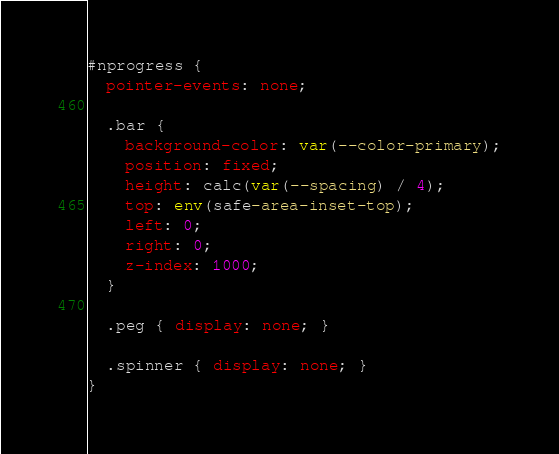<code> <loc_0><loc_0><loc_500><loc_500><_CSS_>#nprogress {
  pointer-events: none;

  .bar {
    background-color: var(--color-primary);
    position: fixed;
    height: calc(var(--spacing) / 4);
    top: env(safe-area-inset-top);
    left: 0;
    right: 0;
    z-index: 1000;
  }

  .peg { display: none; }

  .spinner { display: none; }
}
</code> 